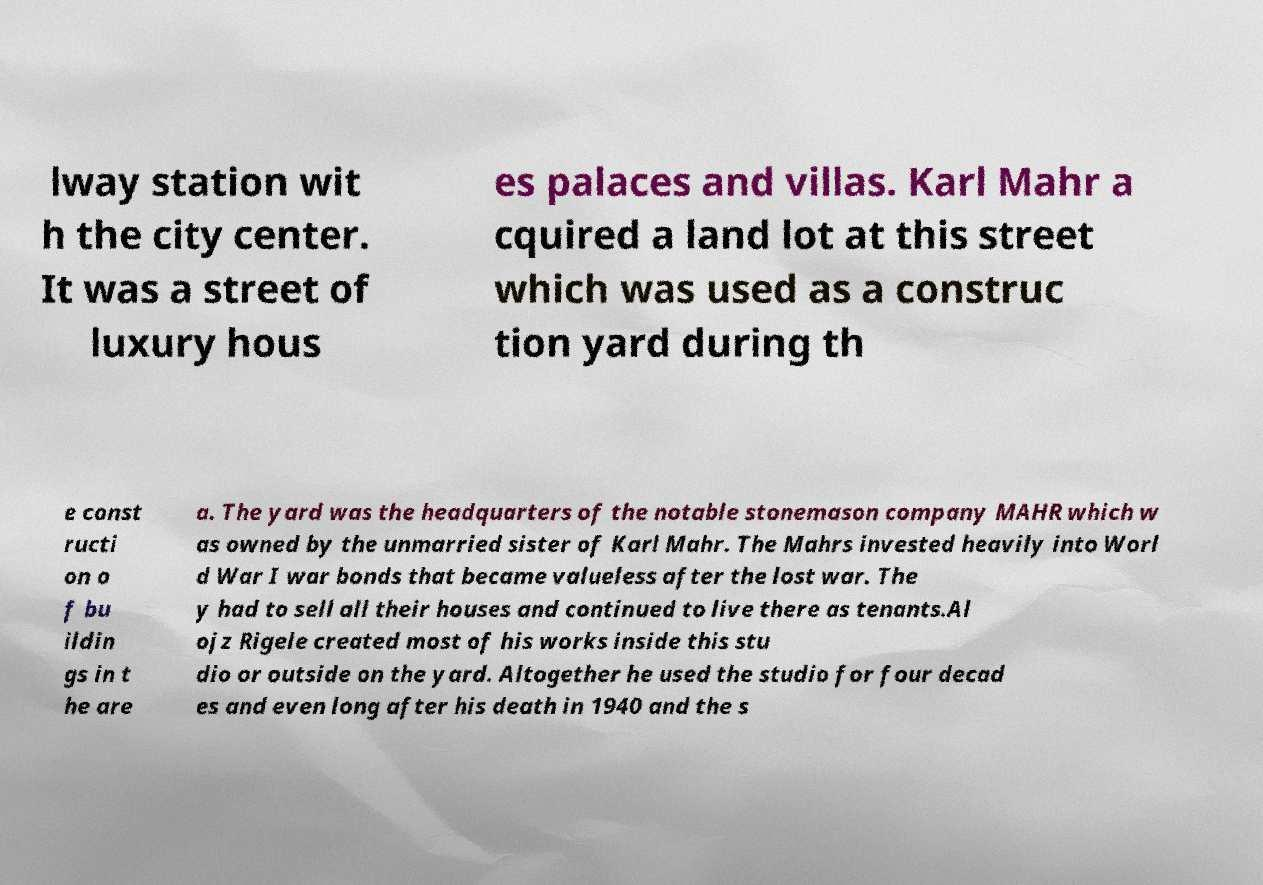There's text embedded in this image that I need extracted. Can you transcribe it verbatim? lway station wit h the city center. It was a street of luxury hous es palaces and villas. Karl Mahr a cquired a land lot at this street which was used as a construc tion yard during th e const ructi on o f bu ildin gs in t he are a. The yard was the headquarters of the notable stonemason company MAHR which w as owned by the unmarried sister of Karl Mahr. The Mahrs invested heavily into Worl d War I war bonds that became valueless after the lost war. The y had to sell all their houses and continued to live there as tenants.Al ojz Rigele created most of his works inside this stu dio or outside on the yard. Altogether he used the studio for four decad es and even long after his death in 1940 and the s 